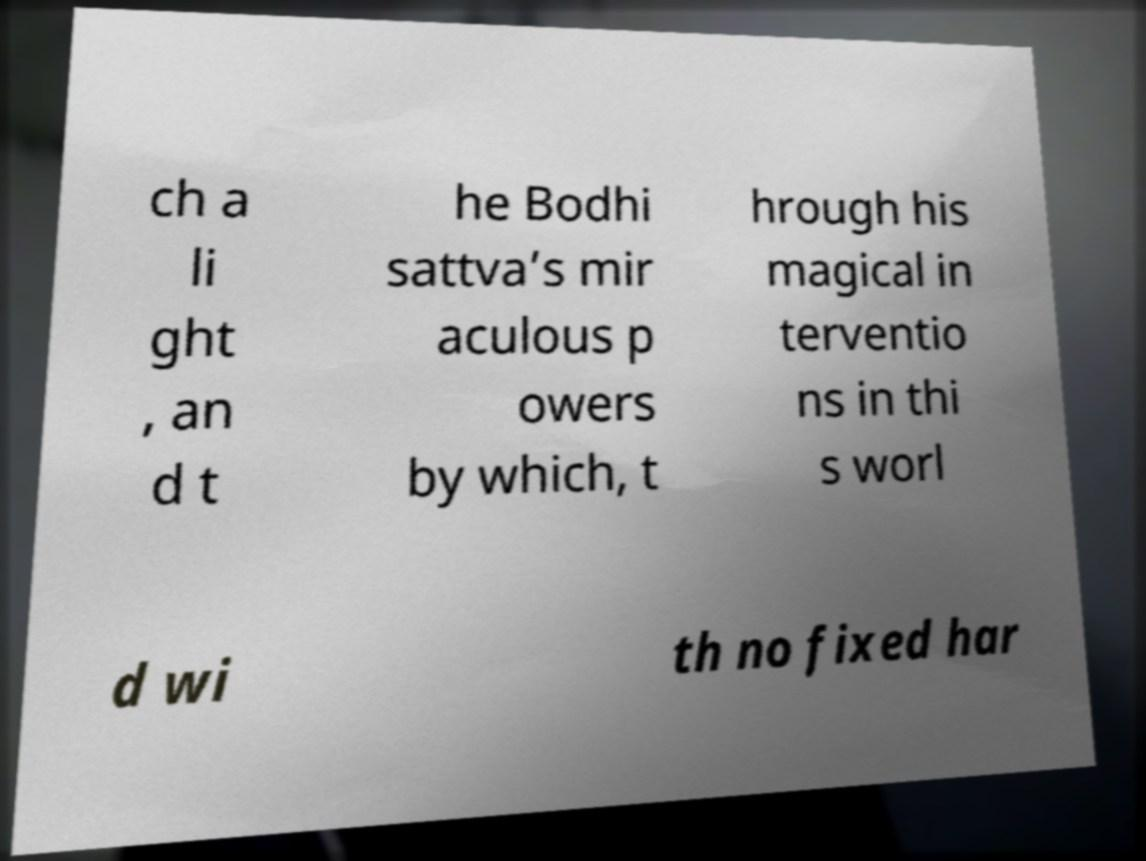Could you extract and type out the text from this image? ch a li ght , an d t he Bodhi sattva’s mir aculous p owers by which, t hrough his magical in terventio ns in thi s worl d wi th no fixed har 